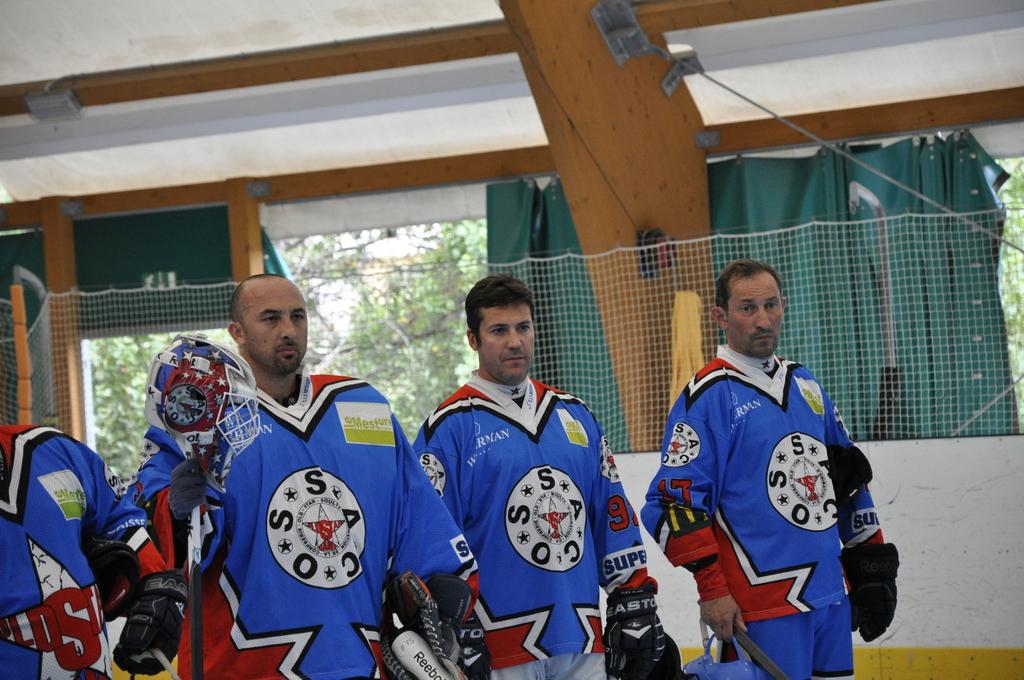What initials are on the jerseys?
Your answer should be very brief. Ssaco. What number is the player on the right?
Provide a succinct answer. 17. 